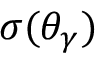Convert formula to latex. <formula><loc_0><loc_0><loc_500><loc_500>\sigma ( \theta _ { \gamma } )</formula> 